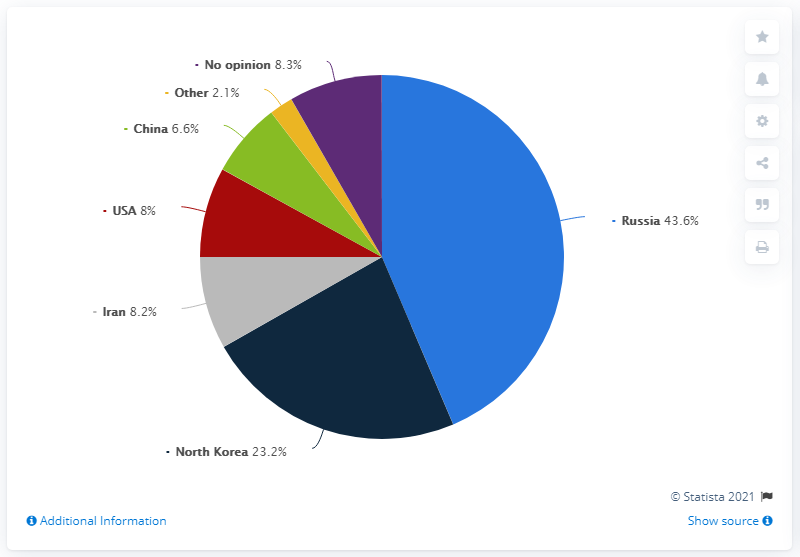Draw attention to some important aspects in this diagram. Five countries have been represented. The difference between the top two countries is 20.4%. According to a survey conducted in Poland in 2020, nearly half of the respondents identified Russia as the country that posed the greatest threat to global security. According to a survey conducted in Poland in 2020, nearly half of the respondents believed that Russia was the country that posed the greatest threat to global security. North Korea was the second most threatening country to global security, according to reports. 